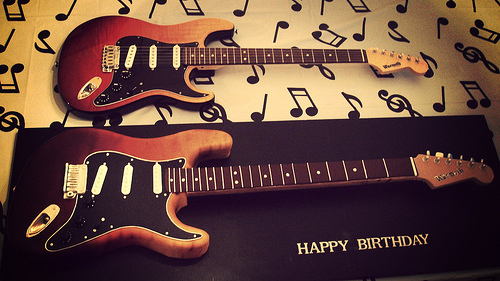<image>
Is the guitar in front of the music note? No. The guitar is not in front of the music note. The spatial positioning shows a different relationship between these objects. 